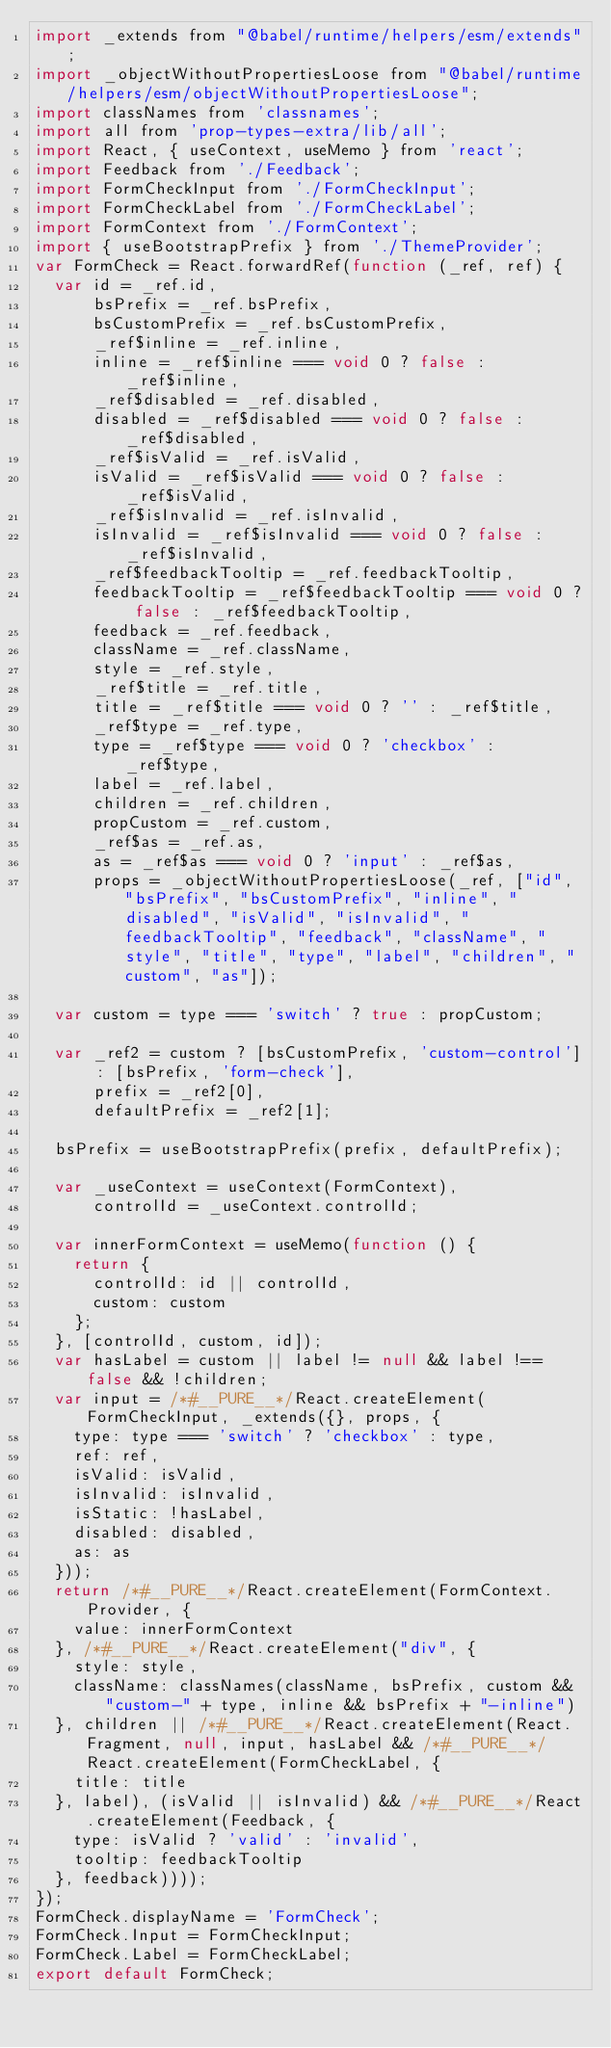Convert code to text. <code><loc_0><loc_0><loc_500><loc_500><_JavaScript_>import _extends from "@babel/runtime/helpers/esm/extends";
import _objectWithoutPropertiesLoose from "@babel/runtime/helpers/esm/objectWithoutPropertiesLoose";
import classNames from 'classnames';
import all from 'prop-types-extra/lib/all';
import React, { useContext, useMemo } from 'react';
import Feedback from './Feedback';
import FormCheckInput from './FormCheckInput';
import FormCheckLabel from './FormCheckLabel';
import FormContext from './FormContext';
import { useBootstrapPrefix } from './ThemeProvider';
var FormCheck = React.forwardRef(function (_ref, ref) {
  var id = _ref.id,
      bsPrefix = _ref.bsPrefix,
      bsCustomPrefix = _ref.bsCustomPrefix,
      _ref$inline = _ref.inline,
      inline = _ref$inline === void 0 ? false : _ref$inline,
      _ref$disabled = _ref.disabled,
      disabled = _ref$disabled === void 0 ? false : _ref$disabled,
      _ref$isValid = _ref.isValid,
      isValid = _ref$isValid === void 0 ? false : _ref$isValid,
      _ref$isInvalid = _ref.isInvalid,
      isInvalid = _ref$isInvalid === void 0 ? false : _ref$isInvalid,
      _ref$feedbackTooltip = _ref.feedbackTooltip,
      feedbackTooltip = _ref$feedbackTooltip === void 0 ? false : _ref$feedbackTooltip,
      feedback = _ref.feedback,
      className = _ref.className,
      style = _ref.style,
      _ref$title = _ref.title,
      title = _ref$title === void 0 ? '' : _ref$title,
      _ref$type = _ref.type,
      type = _ref$type === void 0 ? 'checkbox' : _ref$type,
      label = _ref.label,
      children = _ref.children,
      propCustom = _ref.custom,
      _ref$as = _ref.as,
      as = _ref$as === void 0 ? 'input' : _ref$as,
      props = _objectWithoutPropertiesLoose(_ref, ["id", "bsPrefix", "bsCustomPrefix", "inline", "disabled", "isValid", "isInvalid", "feedbackTooltip", "feedback", "className", "style", "title", "type", "label", "children", "custom", "as"]);

  var custom = type === 'switch' ? true : propCustom;

  var _ref2 = custom ? [bsCustomPrefix, 'custom-control'] : [bsPrefix, 'form-check'],
      prefix = _ref2[0],
      defaultPrefix = _ref2[1];

  bsPrefix = useBootstrapPrefix(prefix, defaultPrefix);

  var _useContext = useContext(FormContext),
      controlId = _useContext.controlId;

  var innerFormContext = useMemo(function () {
    return {
      controlId: id || controlId,
      custom: custom
    };
  }, [controlId, custom, id]);
  var hasLabel = custom || label != null && label !== false && !children;
  var input = /*#__PURE__*/React.createElement(FormCheckInput, _extends({}, props, {
    type: type === 'switch' ? 'checkbox' : type,
    ref: ref,
    isValid: isValid,
    isInvalid: isInvalid,
    isStatic: !hasLabel,
    disabled: disabled,
    as: as
  }));
  return /*#__PURE__*/React.createElement(FormContext.Provider, {
    value: innerFormContext
  }, /*#__PURE__*/React.createElement("div", {
    style: style,
    className: classNames(className, bsPrefix, custom && "custom-" + type, inline && bsPrefix + "-inline")
  }, children || /*#__PURE__*/React.createElement(React.Fragment, null, input, hasLabel && /*#__PURE__*/React.createElement(FormCheckLabel, {
    title: title
  }, label), (isValid || isInvalid) && /*#__PURE__*/React.createElement(Feedback, {
    type: isValid ? 'valid' : 'invalid',
    tooltip: feedbackTooltip
  }, feedback))));
});
FormCheck.displayName = 'FormCheck';
FormCheck.Input = FormCheckInput;
FormCheck.Label = FormCheckLabel;
export default FormCheck;</code> 